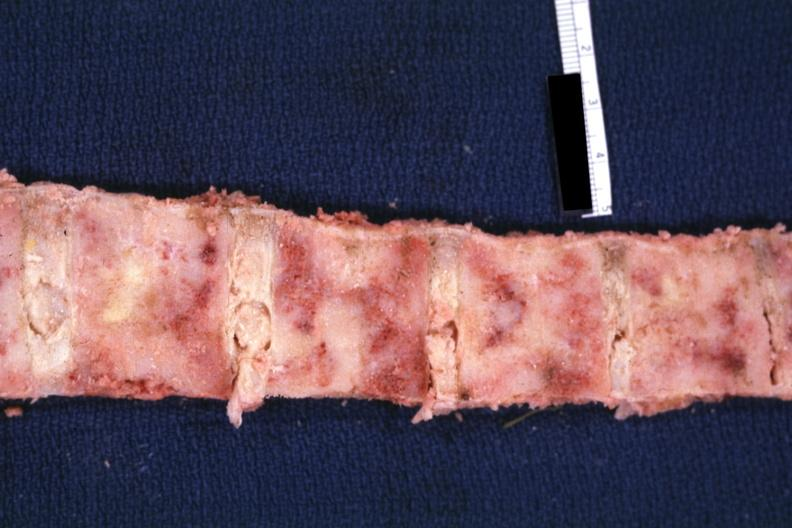s joints present?
Answer the question using a single word or phrase. Yes 